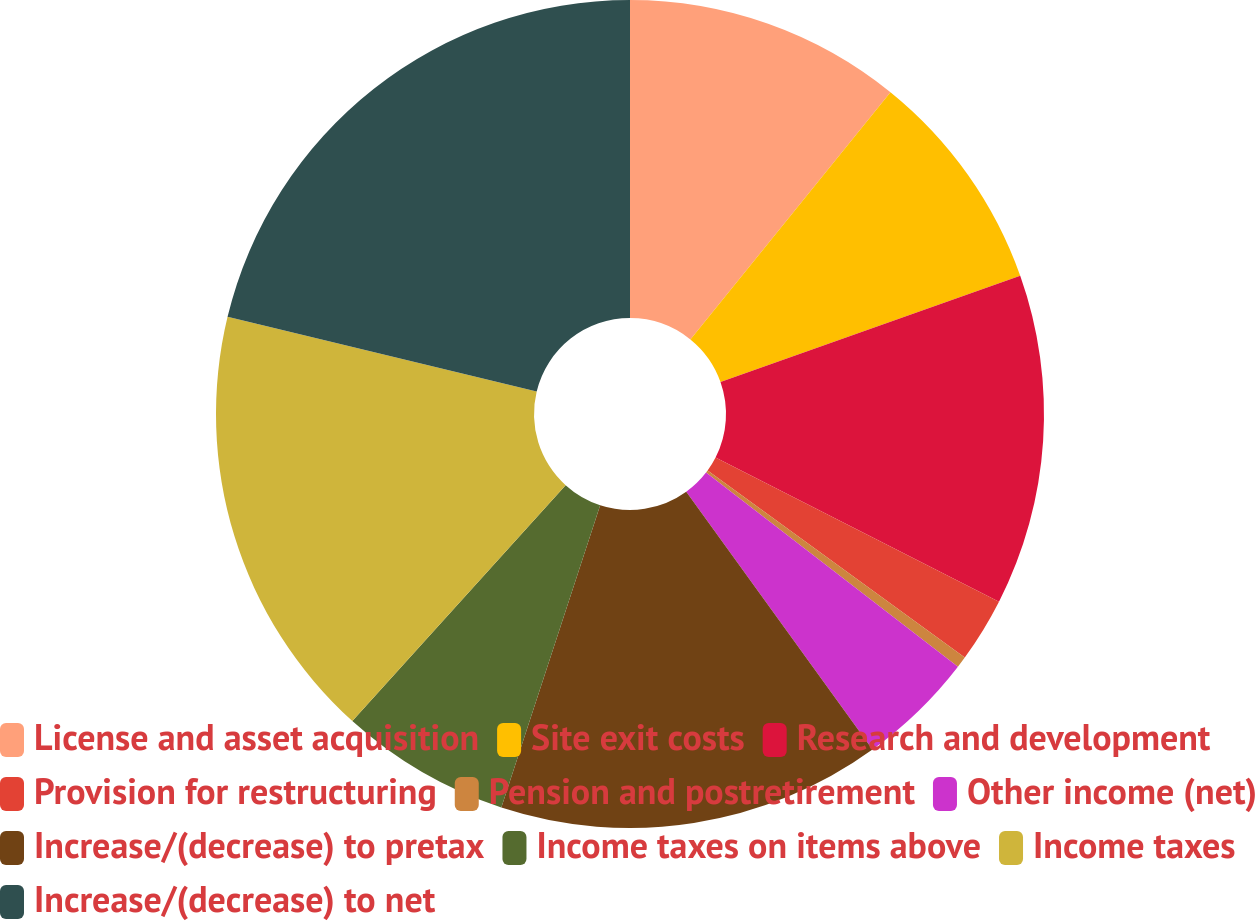<chart> <loc_0><loc_0><loc_500><loc_500><pie_chart><fcel>License and asset acquisition<fcel>Site exit costs<fcel>Research and development<fcel>Provision for restructuring<fcel>Pension and postretirement<fcel>Other income (net)<fcel>Increase/(decrease) to pretax<fcel>Income taxes on items above<fcel>Income taxes<fcel>Increase/(decrease) to net<nl><fcel>10.83%<fcel>8.75%<fcel>12.91%<fcel>2.52%<fcel>0.44%<fcel>4.59%<fcel>14.99%<fcel>6.67%<fcel>17.07%<fcel>21.23%<nl></chart> 